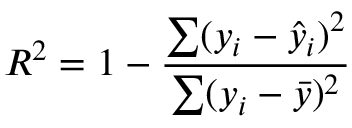<formula> <loc_0><loc_0><loc_500><loc_500>R ^ { 2 } = 1 - \frac { \sum ( y _ { i } - \hat { y } _ { i } ) ^ { 2 } } { \sum ( y _ { i } - \bar { y } ) ^ { 2 } }</formula> 